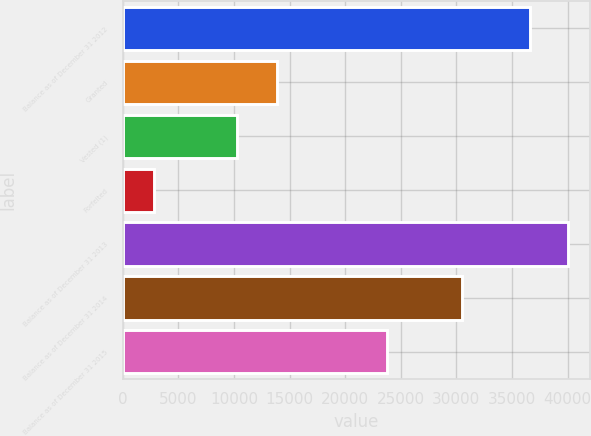<chart> <loc_0><loc_0><loc_500><loc_500><bar_chart><fcel>Balance as of December 31 2012<fcel>Granted<fcel>Vested (1)<fcel>Forfeited<fcel>Balance as of December 31 2013<fcel>Balance as of December 31 2014<fcel>Balance as of December 31 2015<nl><fcel>36593<fcel>13913<fcel>10307<fcel>2860<fcel>40040.9<fcel>30535<fcel>23764<nl></chart> 